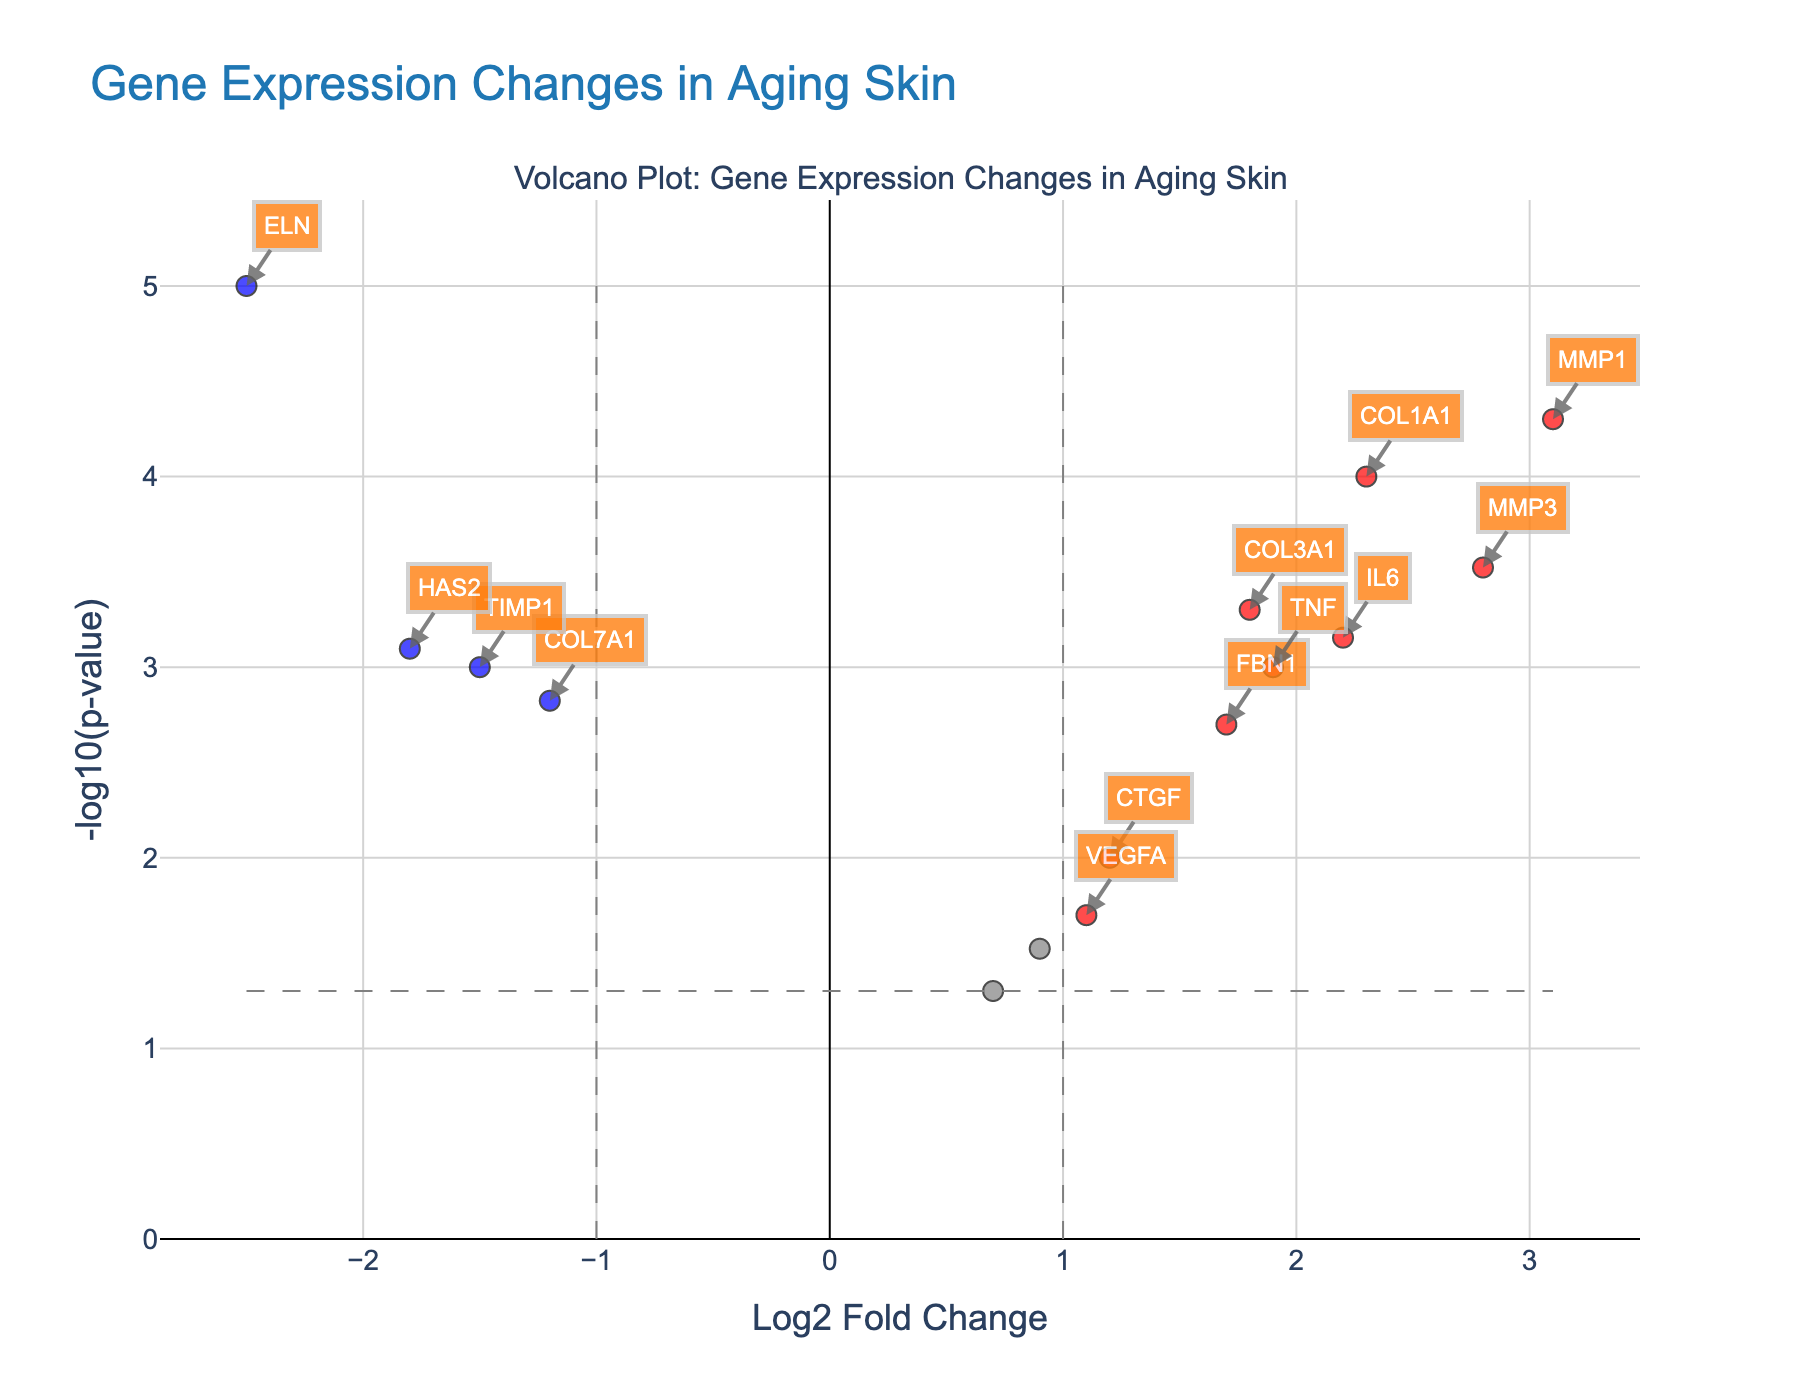Which gene has the highest Log2 fold change? To determine the gene with the highest Log2 fold change, we look at the x-axis which represents Log2 Fold Change and find the data point farthest to the right. This is the gene MMP1.
Answer: MMP1 Which gene has the lowest p-value? The y-axis represents the -log10(p-value). To find the gene with the lowest p-value, locate the point highest on the y-axis as this correspond to the smallest p-value. This gene is ELN.
Answer: ELN How many genes are significantly downregulated? To determine significantly downregulated genes, check for genes having a Log2 fold change less than -1 and a p-value less than 0.05. These are shown as blue points. From the plot, the genes are ELN, COL7A1, HAS2, and TIMP1.
Answer: 4 What is the Log2 fold change of COL1A1 and does it surpass the significance threshold? COL1A1 has a Log2 fold change which can be found by looking for the data point labeled "COL1A1" on the plot. The Log2 fold change is 2.3 which is above the threshold of 1, showing it is significant.
Answer: 2.3, Yes Which genes are specifically related to skin elasticity and where are they located on the plot? Check the genes in the dataset that relate to skin elasticity: COL1A1, COL3A1, ELN. COL1A1 and COL3A1 are upregulated (right of 0), ELN is downregulated (left of 0); all are significant as they surpass Log2FC thresholds.
Answer: COL1A1, COL3A1 (right); ELN (left) What pattern do we observe for MMP1 and MMP3 in terms of gene expression changes in aging skin? For MMP1 and MMP3, locate these genes on the plot; both have high positive Log2 fold changes and low p-values indicating significant upregulation in aging skin.
Answer: Both are significantly upregulated How does the gene IL6 compare to TNF in terms of fold change and significance? Find IL6 and TNF on the plot; both are upregulated. IL6 has a Log2 fold change of 2.2 and TNF has 1.9. Both are above the threshold of 1 in fold change and have significant p-values.
Answer: IL6 has a higher fold change and both are significant 